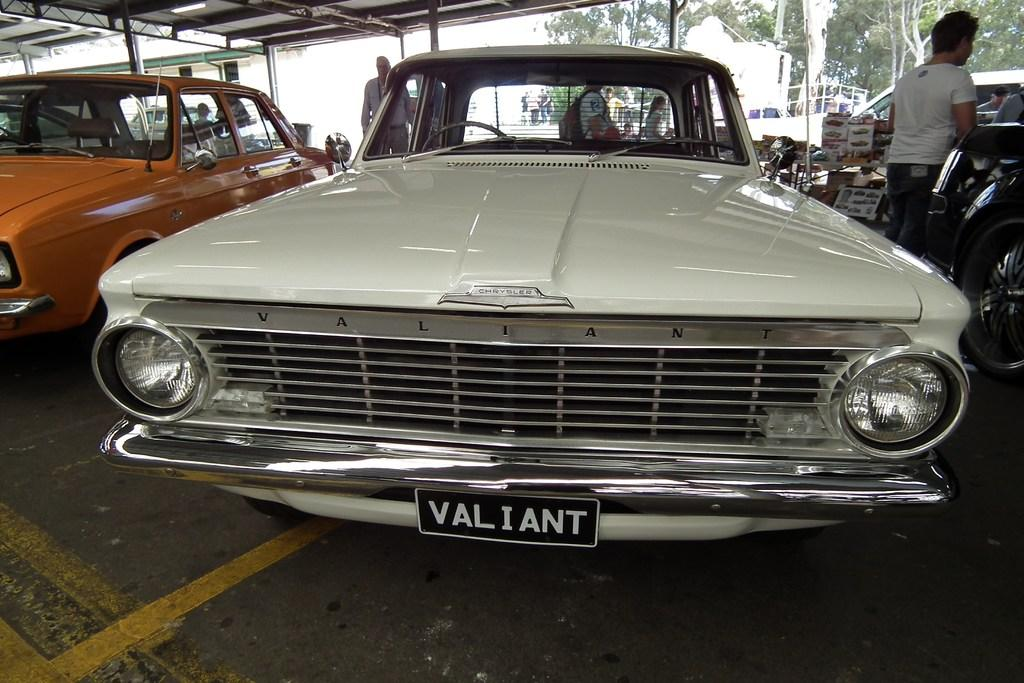What type of vehicles are on the ground in the image? There are cars on the ground in the image. Who or what can be seen at the back of the cars? There are people visible at the back of the cars. What structure is present in the image for providing shelter? There is a shelter in the image. What type of natural vegetation is present in the image? Trees are present in the image. Can you describe any other objects in the image? There are some unspecified objects in the image. What type of adjustment can be seen being made to the harmony of the noise in the image? There is no mention of adjustment, harmony, or noise in the image; it features cars, people, a shelter, trees, and unspecified objects. 